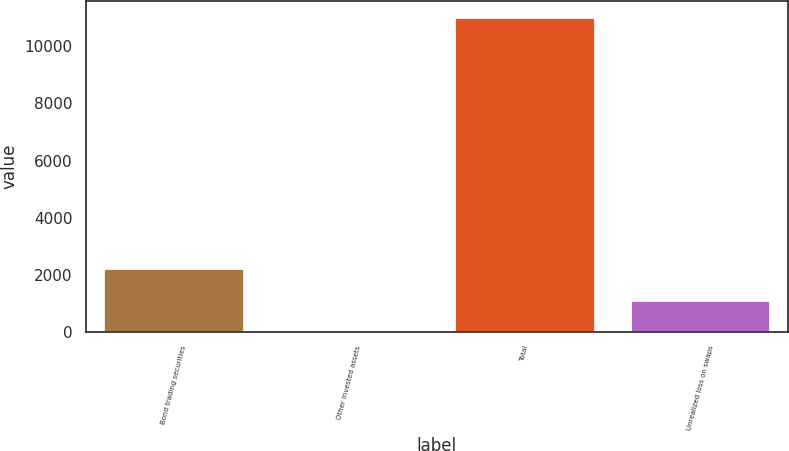Convert chart to OTSL. <chart><loc_0><loc_0><loc_500><loc_500><bar_chart><fcel>Bond trading securities<fcel>Other invested assets<fcel>Total<fcel>Unrealized loss on swaps<nl><fcel>2226.2<fcel>23<fcel>11039<fcel>1124.6<nl></chart> 